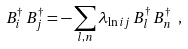<formula> <loc_0><loc_0><loc_500><loc_500>B _ { i } ^ { \dag } \, B _ { j } ^ { \dag } = - \sum _ { l , n } \lambda _ { \ln i j } \, B _ { l } ^ { \dag } \, B _ { n } ^ { \dag } \ ,</formula> 